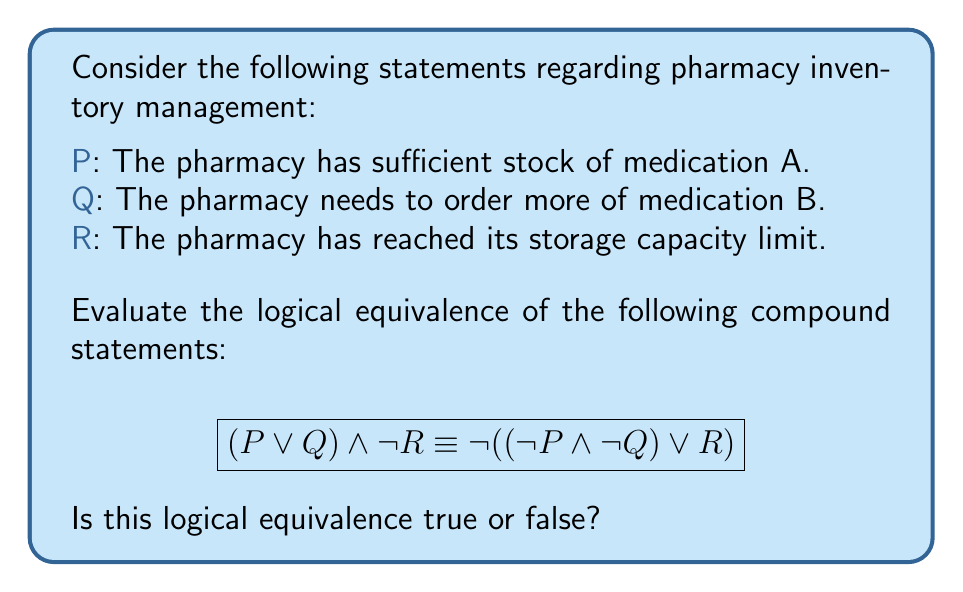What is the answer to this math problem? To evaluate the logical equivalence, we'll use a step-by-step approach:

1) First, let's expand the right side of the equivalence using De Morgan's Law:
   $\lnot((\lnot P \land \lnot Q) \lor R) \equiv \lnot(\lnot P \land \lnot Q) \land \lnot R$

2) Apply De Morgan's Law again to $\lnot(\lnot P \land \lnot Q)$:
   $(P \lor Q) \land \lnot R$

3) Now we have:
   $(P \lor Q) \land \lnot R \equiv (P \lor Q) \land \lnot R$

4) These statements are identical, which means they are logically equivalent.

In the context of pharmacy inventory management:
- $(P \lor Q)$ means either the pharmacy has sufficient stock of medication A or needs to order more of medication B (or both).
- $\lnot R$ means the pharmacy has not reached its storage capacity limit.

The logical equivalence shows that these two ways of expressing the inventory situation are the same.
Answer: True 